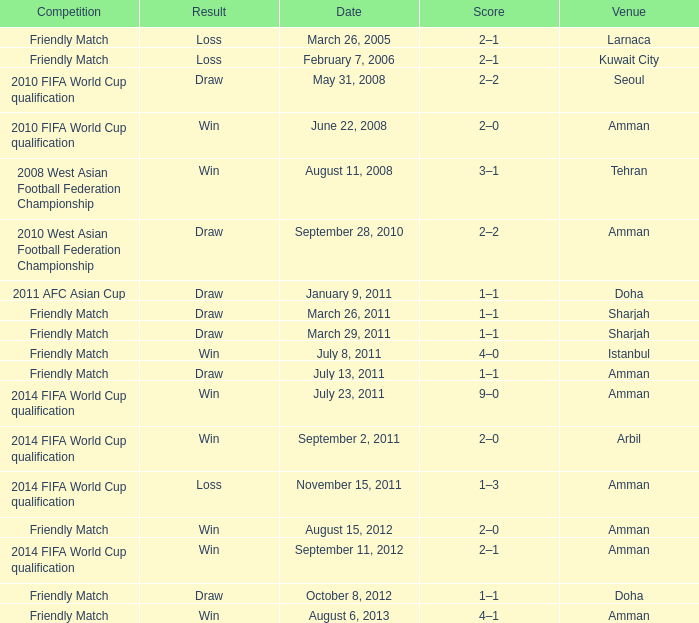WHat was the result of the friendly match that was played on october 8, 2012? Draw. 